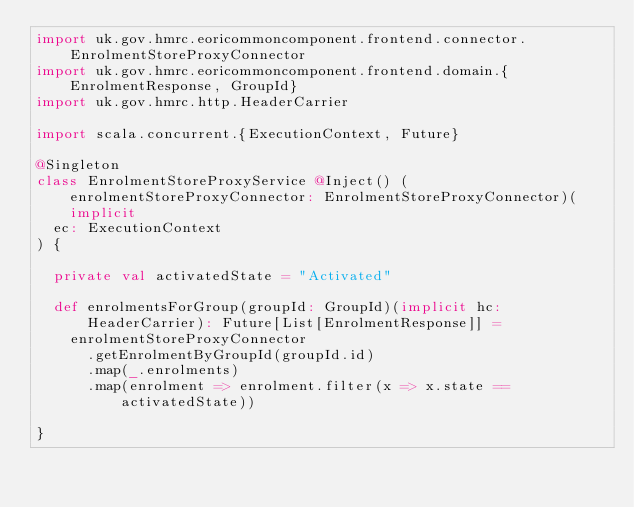<code> <loc_0><loc_0><loc_500><loc_500><_Scala_>import uk.gov.hmrc.eoricommoncomponent.frontend.connector.EnrolmentStoreProxyConnector
import uk.gov.hmrc.eoricommoncomponent.frontend.domain.{EnrolmentResponse, GroupId}
import uk.gov.hmrc.http.HeaderCarrier

import scala.concurrent.{ExecutionContext, Future}

@Singleton
class EnrolmentStoreProxyService @Inject() (enrolmentStoreProxyConnector: EnrolmentStoreProxyConnector)(implicit
  ec: ExecutionContext
) {

  private val activatedState = "Activated"

  def enrolmentsForGroup(groupId: GroupId)(implicit hc: HeaderCarrier): Future[List[EnrolmentResponse]] =
    enrolmentStoreProxyConnector
      .getEnrolmentByGroupId(groupId.id)
      .map(_.enrolments)
      .map(enrolment => enrolment.filter(x => x.state == activatedState))

}
</code> 